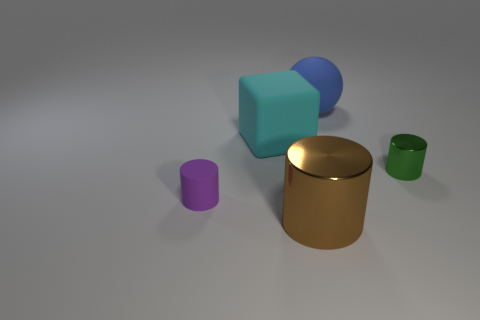Do the blue sphere and the brown object have the same size?
Your answer should be very brief. Yes. What number of green metal cylinders have the same size as the blue thing?
Your answer should be compact. 0. There is another rubber thing that is the same size as the cyan object; what is its color?
Make the answer very short. Blue. What is the size of the purple cylinder?
Ensure brevity in your answer.  Small. What is the size of the metallic object that is to the right of the rubber thing behind the big cyan block?
Offer a terse response. Small. There is a blue object on the right side of the brown cylinder; does it have the same shape as the metal object that is in front of the tiny metallic object?
Offer a terse response. No. There is a tiny thing in front of the tiny object on the right side of the cyan rubber thing; what shape is it?
Ensure brevity in your answer.  Cylinder. There is a cylinder that is both in front of the tiny shiny cylinder and right of the purple matte cylinder; what is its size?
Your response must be concise. Large. There is a green metal thing; does it have the same shape as the large object in front of the tiny matte object?
Keep it short and to the point. Yes. What is the size of the brown object that is the same shape as the purple thing?
Provide a short and direct response. Large. 